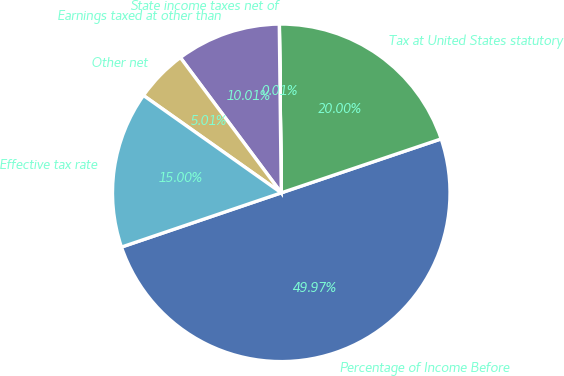Convert chart. <chart><loc_0><loc_0><loc_500><loc_500><pie_chart><fcel>Percentage of Income Before<fcel>Tax at United States statutory<fcel>State income taxes net of<fcel>Earnings taxed at other than<fcel>Other net<fcel>Effective tax rate<nl><fcel>49.97%<fcel>20.0%<fcel>0.01%<fcel>10.01%<fcel>5.01%<fcel>15.0%<nl></chart> 